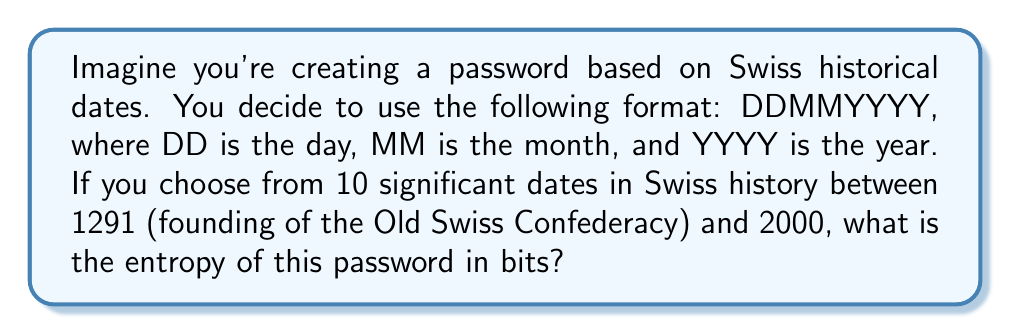Solve this math problem. To calculate the entropy of the password, we need to follow these steps:

1. Determine the number of possible passwords:
   - We have 10 significant dates to choose from.
   - Each date is represented in the format DDMMYYYY.
   - Therefore, the number of possible passwords is 10.

2. Calculate the entropy using the formula:
   $$ H = \log_2(N) $$
   Where:
   - $H$ is the entropy in bits
   - $N$ is the number of possible passwords

3. Plug in the values:
   $$ H = \log_2(10) $$

4. Calculate the result:
   $$ H = 3.32192809488736 \text{ bits} $$

5. Round to two decimal places:
   $$ H \approx 3.32 \text{ bits} $$

This low entropy indicates that the password is not very secure, as there are only 10 possible options, making it relatively easy for an attacker to guess or brute-force the password.
Answer: 3.32 bits 